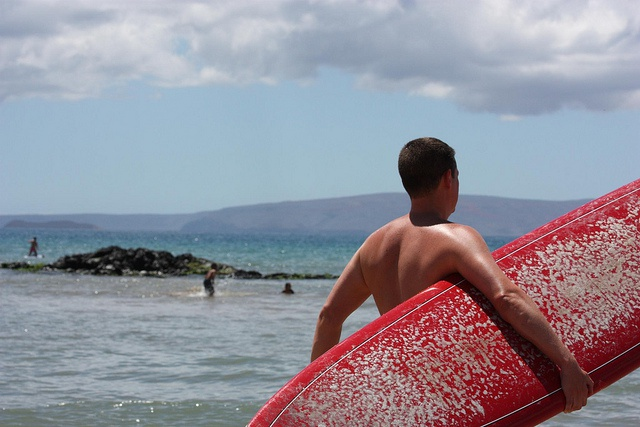Describe the objects in this image and their specific colors. I can see surfboard in darkgray, brown, and maroon tones, people in darkgray, maroon, black, and brown tones, people in darkgray, black, and gray tones, people in darkgray, gray, and black tones, and people in darkgray, black, and gray tones in this image. 